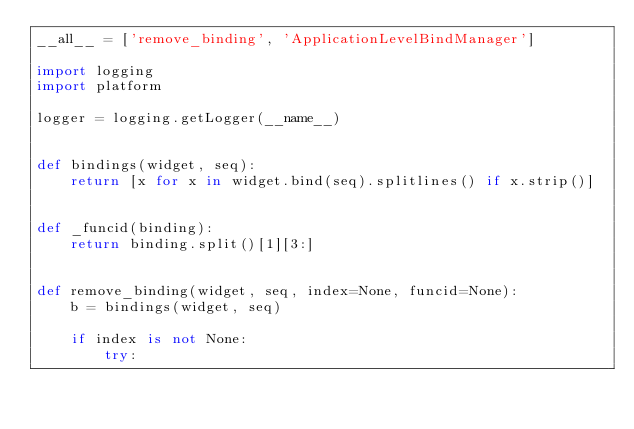Convert code to text. <code><loc_0><loc_0><loc_500><loc_500><_Python_>__all__ = ['remove_binding', 'ApplicationLevelBindManager']

import logging
import platform

logger = logging.getLogger(__name__)


def bindings(widget, seq):
    return [x for x in widget.bind(seq).splitlines() if x.strip()]


def _funcid(binding):
    return binding.split()[1][3:]


def remove_binding(widget, seq, index=None, funcid=None):
    b = bindings(widget, seq)

    if index is not None:
        try:</code> 